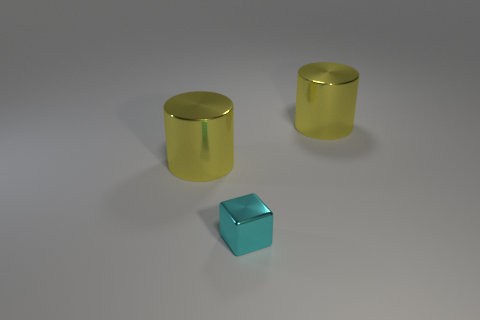What number of large cylinders are the same material as the small block? There are two large cylinders that appear to be made of the same glossy material as the small block. 